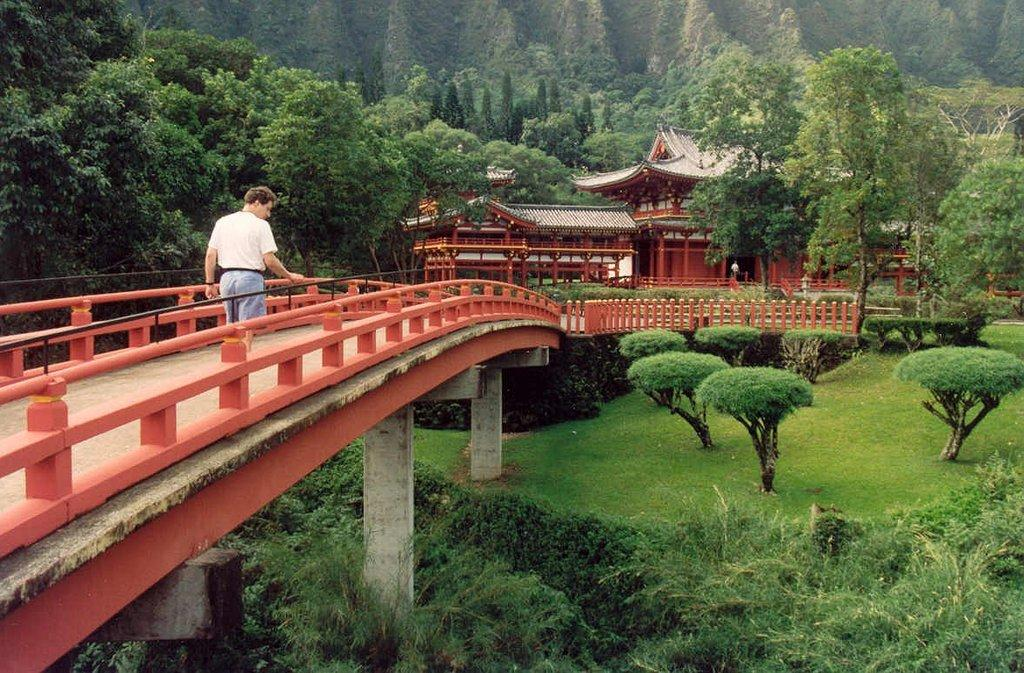What is the man in the image doing? The man is standing on a bridge in the image. What can be seen in the background of the image? There are houses, trees, grass, plants, and a fence in the background of the image. Are there any other objects visible in the background? Yes, there are other unspecified objects in the background of the image. What letter is the man writing on the cord in the image? There is no letter or cord present in the image; the man is simply standing on the bridge. 